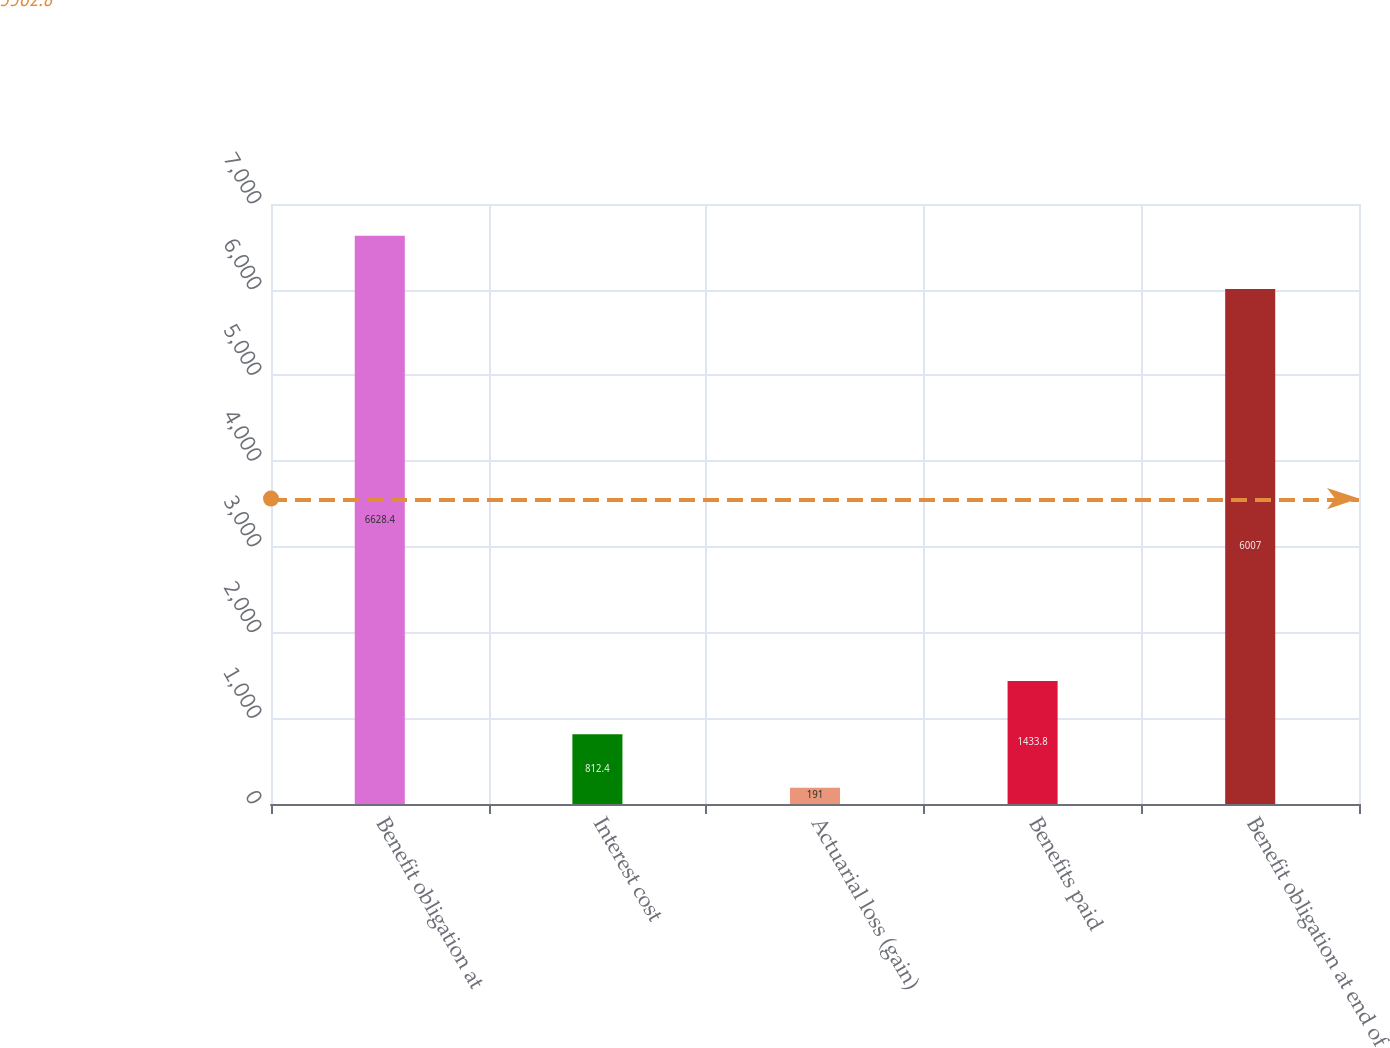Convert chart to OTSL. <chart><loc_0><loc_0><loc_500><loc_500><bar_chart><fcel>Benefit obligation at<fcel>Interest cost<fcel>Actuarial loss (gain)<fcel>Benefits paid<fcel>Benefit obligation at end of<nl><fcel>6628.4<fcel>812.4<fcel>191<fcel>1433.8<fcel>6007<nl></chart> 